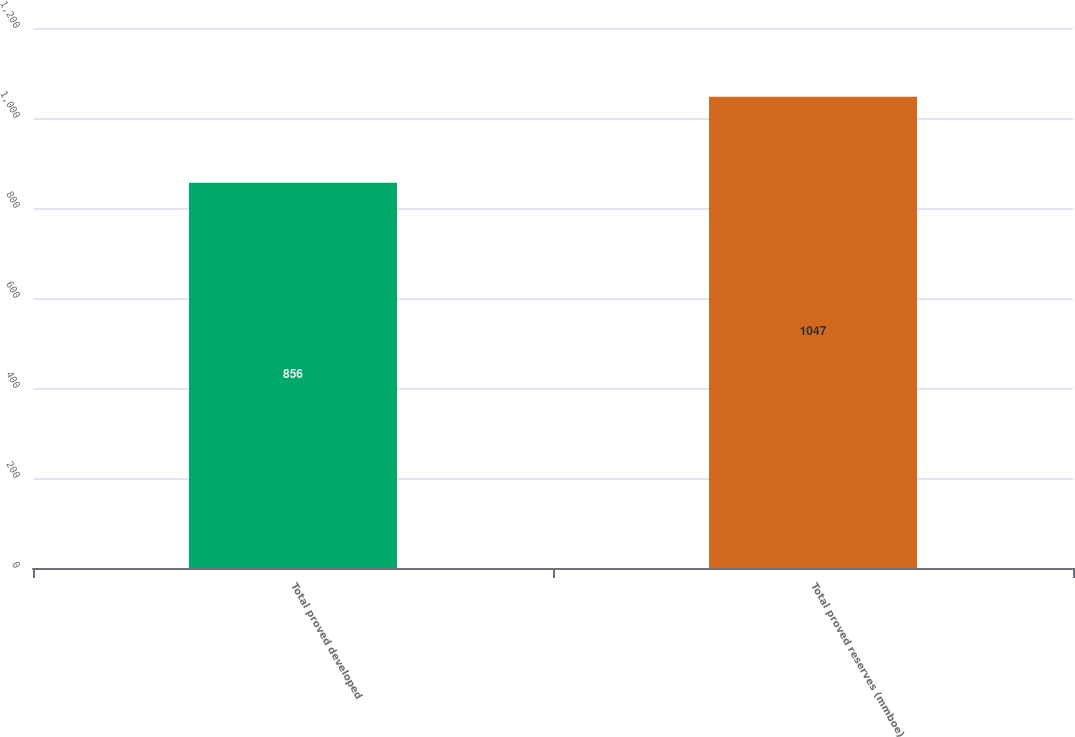Convert chart to OTSL. <chart><loc_0><loc_0><loc_500><loc_500><bar_chart><fcel>Total proved developed<fcel>Total proved reserves (mmboe)<nl><fcel>856<fcel>1047<nl></chart> 